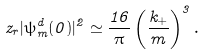Convert formula to latex. <formula><loc_0><loc_0><loc_500><loc_500>z _ { r } | \psi ^ { d } _ { m } ( 0 ) | ^ { 2 } \simeq \frac { 1 6 } { \pi } \left ( \frac { k _ { + } } { m } \right ) ^ { 3 } .</formula> 